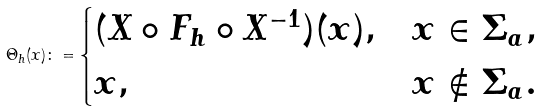Convert formula to latex. <formula><loc_0><loc_0><loc_500><loc_500>\Theta _ { h } ( x ) \colon = \begin{cases} ( X \circ F _ { h } \circ X ^ { - 1 } ) ( x ) , & x \in \Sigma _ { a } , \\ x , & x \not \in \Sigma _ { a } . \end{cases}</formula> 